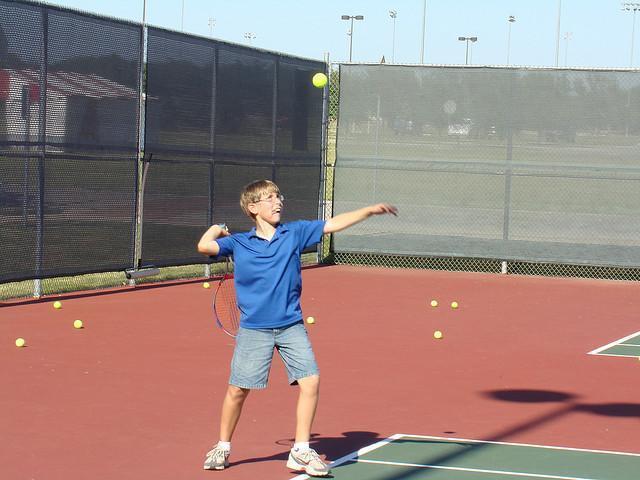What type of shot is the boy about to hit?
Indicate the correct response by choosing from the four available options to answer the question.
Options: Backhand, slice, forehand, serve. Serve. 